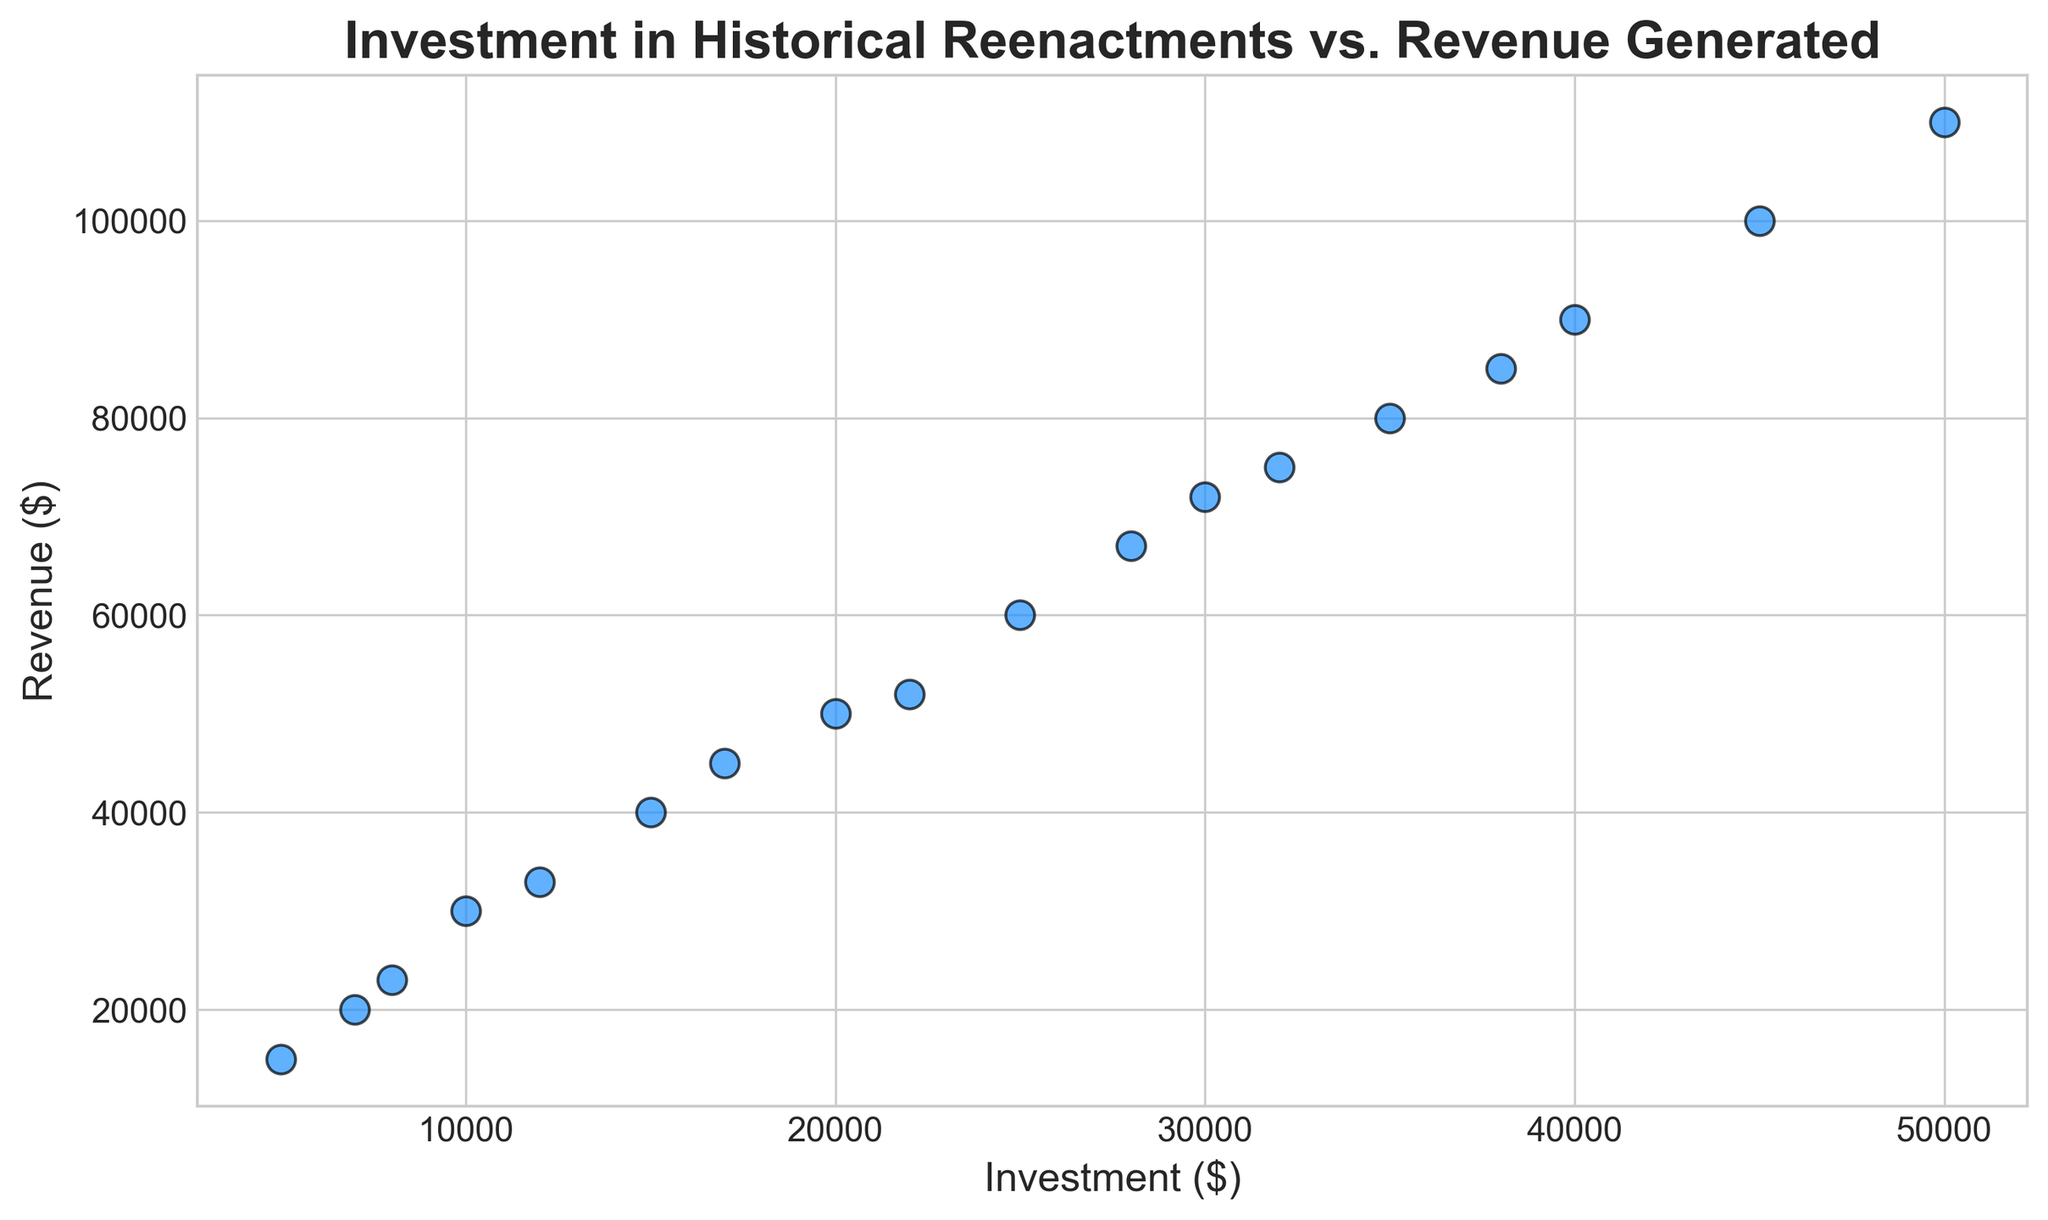What is the investment amount when the revenue is $50,000? Based on the scatter plot, identify the data point where the revenue value is closest to $50,000. The corresponding investment amount is $20,000.
Answer: $20,000 Which investment level corresponds to the highest revenue? Locate the highest point on the Y-axis representing revenue. The highest revenue is $110,000, corresponding to an investment of $50,000.
Answer: $50,000 How does the revenue at an investment of $15,000 compare with the revenue at an investment of $30,000? Check the plot for points corresponding to investments of $15,000 and $30,000. The revenue at $15,000 investment is $40,000, and at $30,000 investment is $72,000. The revenue at $30,000 investment is greater.
Answer: $30,000 investment has higher revenue What is the proportional increase in revenue from an investment of $10,000 to $20,000? Determine the revenue at both investment points ($10,000: $30,000, $20,000: $50,000). Calculate the increase as $50,000 - $30,000 = $20,000. The proportional increase is $20,000 / $30,000 = 0.67, or 67%.
Answer: 67% What is the average revenue generated from investments ranging from $20,000 to $40,000? Identify the data points within the range $20,000 to $40,000 and their corresponding revenues ($50,000, $52,000, $60,000, $67,000, $72,000, $75,000, $80,000, $85,000, $90,000). Sum these values and divide by their count. (Sum: $621,000, Count: 9, Average: $621,000 / 9 = $69,000)
Answer: $69,000 What is the color used for the data points in the scatter plot? Observation of the scatter plot's visual attributes shows that the color of the data points is dodger blue.
Answer: Blue What is the difference in revenue between the highest and lowest investment values? The highest revenue corresponds to $50,000 investment ($110,000) and the lowest to $5,000 investment ($15,000). The difference is $110,000 - $15,000 = $95,000.
Answer: $95,000 What is the trend seen as investments increase? Visually, as investment amounts increase, the revenue also increases, showing a positive trend.
Answer: Positive trend 